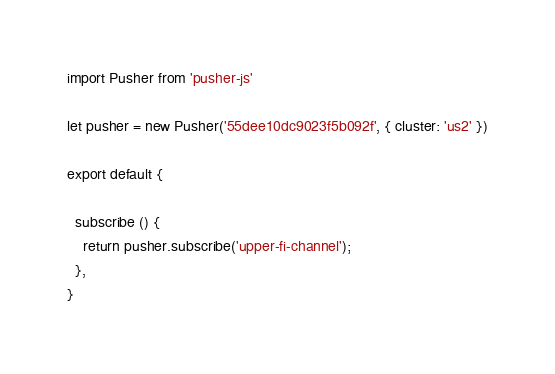Convert code to text. <code><loc_0><loc_0><loc_500><loc_500><_JavaScript_>import Pusher from 'pusher-js'

let pusher = new Pusher('55dee10dc9023f5b092f', { cluster: 'us2' })

export default {

  subscribe () {
    return pusher.subscribe('upper-fi-channel');
  },
}</code> 